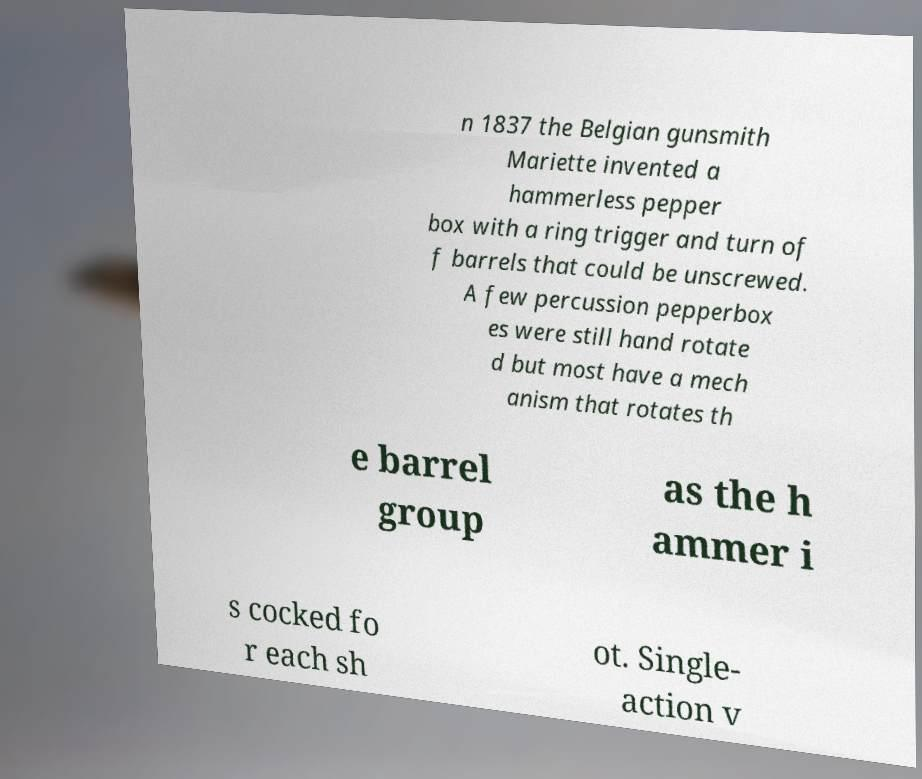Please identify and transcribe the text found in this image. n 1837 the Belgian gunsmith Mariette invented a hammerless pepper box with a ring trigger and turn of f barrels that could be unscrewed. A few percussion pepperbox es were still hand rotate d but most have a mech anism that rotates th e barrel group as the h ammer i s cocked fo r each sh ot. Single- action v 